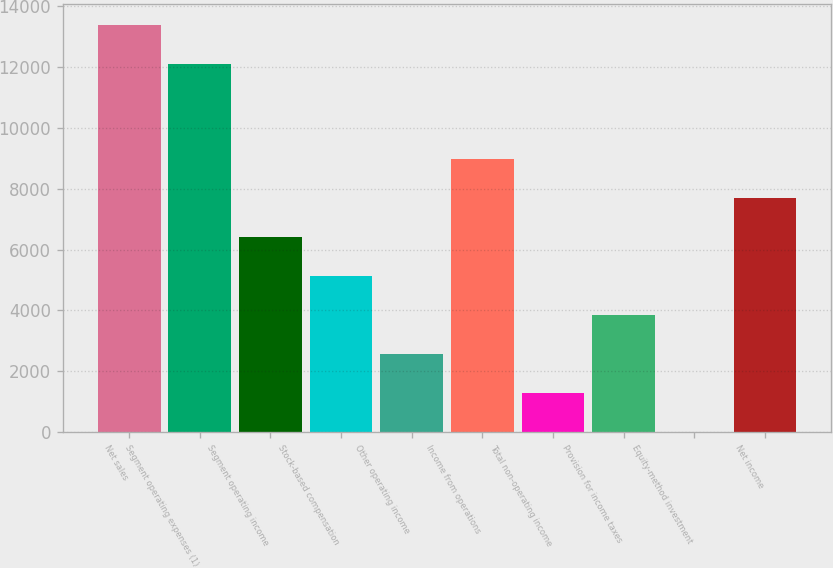Convert chart to OTSL. <chart><loc_0><loc_0><loc_500><loc_500><bar_chart><fcel>Net sales<fcel>Segment operating expenses (1)<fcel>Segment operating income<fcel>Stock-based compensation<fcel>Other operating income<fcel>Income from operations<fcel>Total non-operating income<fcel>Provision for income taxes<fcel>Equity-method investment<fcel>Net income<nl><fcel>13401.2<fcel>12119<fcel>6417<fcel>5134.8<fcel>2570.4<fcel>8981.4<fcel>1288.2<fcel>3852.6<fcel>6<fcel>7699.2<nl></chart> 